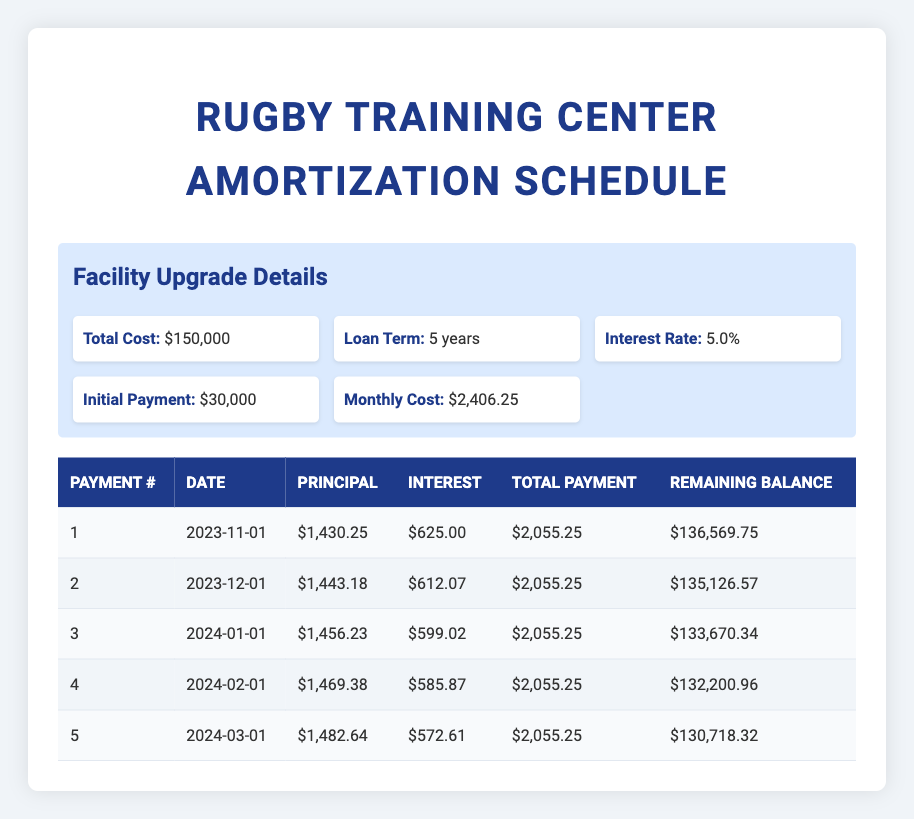What is the total cost of the facility upgrades? The total cost listed in the facility upgrade details section is $150,000.
Answer: 150,000 What is the monthly payment during the loan term? The monthly cost listed in the facility upgrade details is $2,406.25.
Answer: 2,406.25 In which month is the second payment due? The payment date for the second payment is listed as December 1, 2023.
Answer: December 1, 2023 How much is the principal payment for the first payment? The principal payment for the first payment is explicitly stated as $1,430.25.
Answer: 1,430.25 What is the remaining balance after the fifth payment? The remaining balance after the fifth payment is listed as $130,718.32.
Answer: 130,718.32 What is the total interest payment for the first five payments? To find the total interest, we add the interest payments for the five payments: 625.00 + 612.07 + 599.02 + 585.87 + 572.61 = 3,594.57.
Answer: 3,594.57 Did the principal payment increase or decrease with each subsequent payment? The principal payments have increased from $1,430.25 to $1,482.64, indicating an increase with each payment.
Answer: Yes What will be the remaining balance after the third payment compared to the initial balance after the first payment? The initial balance after the first payment is $136,569.75, and the remaining balance after the third payment is $133,670.34. Therefore, the remaining balance decreased by $2,899.41 after two additional payments.
Answer: Decreased by 2,899.41 What is the average monthly principal payment for the first five payments? The principal payments for the first five payments are $1,430.25, $1,443.18, $1,456.23, $1,469.38, and $1,482.64. Summing these gives $7,281.68, and dividing by 5 gives an average of $1,456.34.
Answer: 1,456.34 